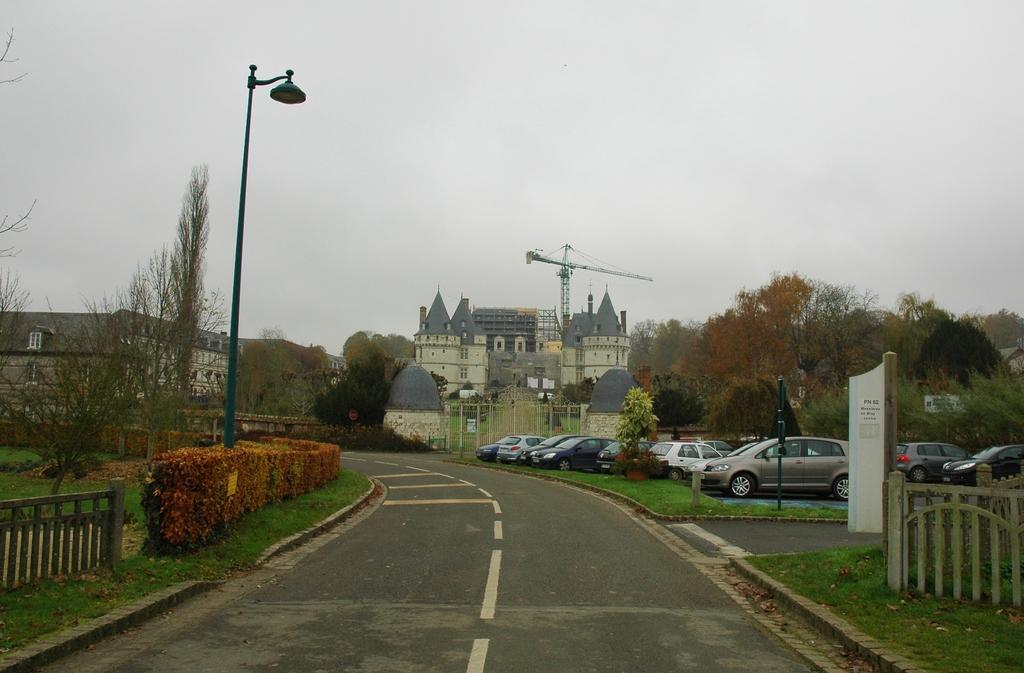Can you describe this image briefly? This picture might be taken on the wide road. In this picture, on the right side, we can see a hoarding, wood grill and few cars which are placed on the road, plant, trees. On the left side, we can see a street light, plants, trees, building. In the background, we can see some cars, building, trees, rotator. At the top, we can see a sky, at the bottom, we can see a road and a grass. 